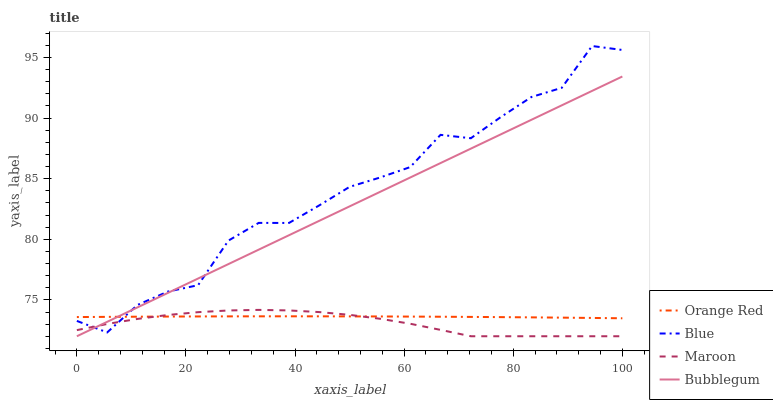Does Maroon have the minimum area under the curve?
Answer yes or no. Yes. Does Blue have the maximum area under the curve?
Answer yes or no. Yes. Does Bubblegum have the minimum area under the curve?
Answer yes or no. No. Does Bubblegum have the maximum area under the curve?
Answer yes or no. No. Is Bubblegum the smoothest?
Answer yes or no. Yes. Is Blue the roughest?
Answer yes or no. Yes. Is Orange Red the smoothest?
Answer yes or no. No. Is Orange Red the roughest?
Answer yes or no. No. Does Bubblegum have the lowest value?
Answer yes or no. Yes. Does Orange Red have the lowest value?
Answer yes or no. No. Does Blue have the highest value?
Answer yes or no. Yes. Does Bubblegum have the highest value?
Answer yes or no. No. Does Blue intersect Bubblegum?
Answer yes or no. Yes. Is Blue less than Bubblegum?
Answer yes or no. No. Is Blue greater than Bubblegum?
Answer yes or no. No. 